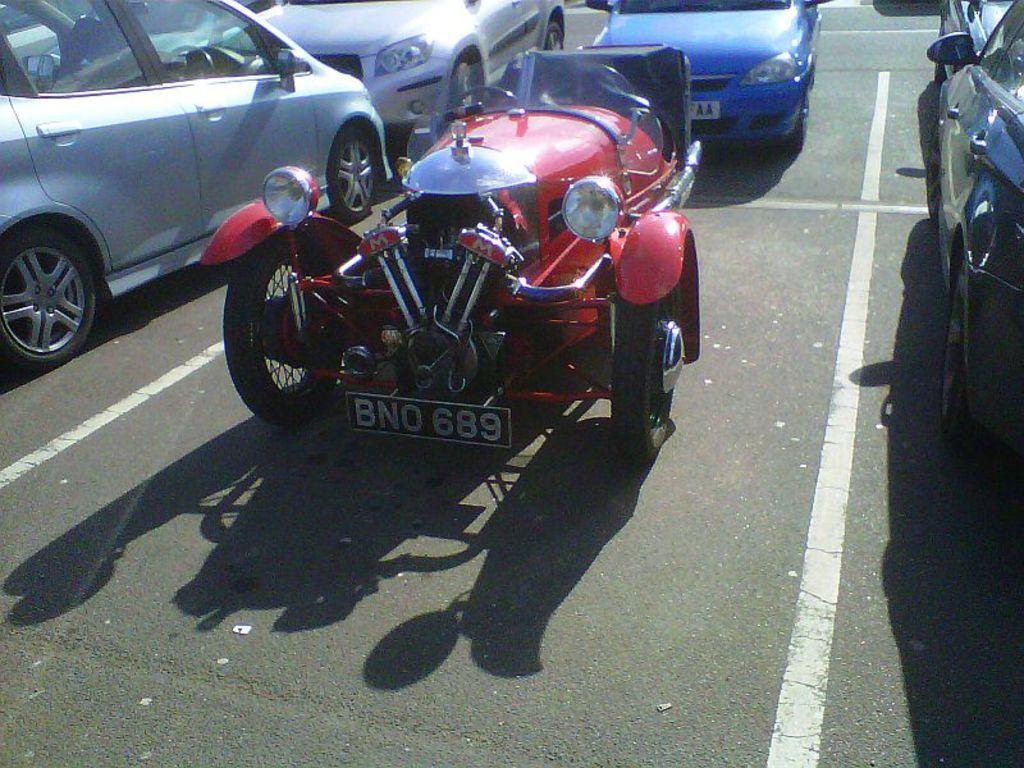Describe this image in one or two sentences. In the center of the image we can see a few different color vehicles on the road. 